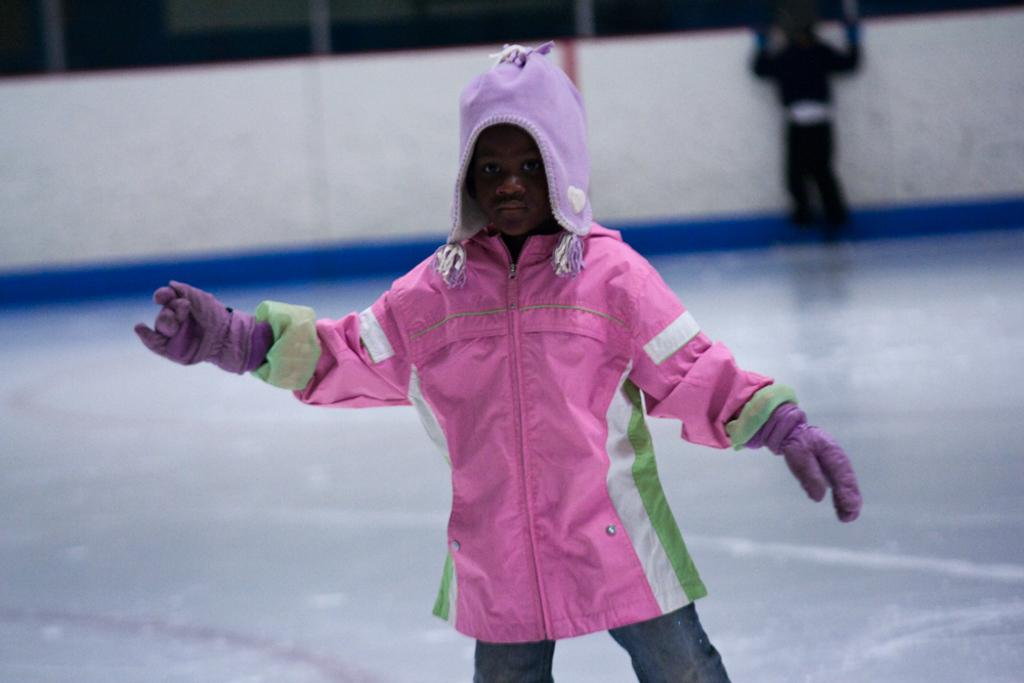What is the main subject of the image? The main subject of the image is a kid. What is the kid wearing? The kid is wearing a pink color sweater and a purple color head wear. Where is the kid standing? The kid is standing in the ice. Can you describe the other kid in the image? There is another kid in the background of the image. What type of toothbrush is the kid using in the image? There is no toothbrush present in the image. Can you describe the hill in the background of the image? There is no hill present in the image; the kid is standing in the ice. 